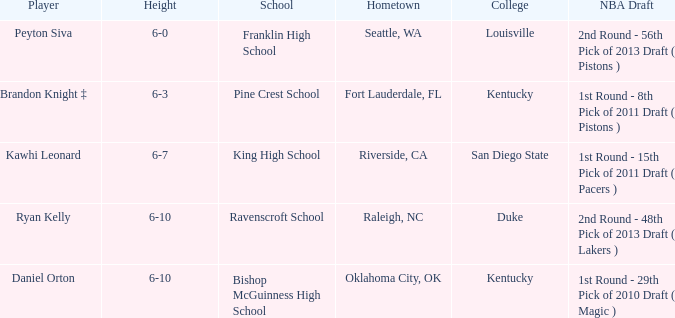Can you identify the school situated in raleigh, nc? Ravenscroft School. 